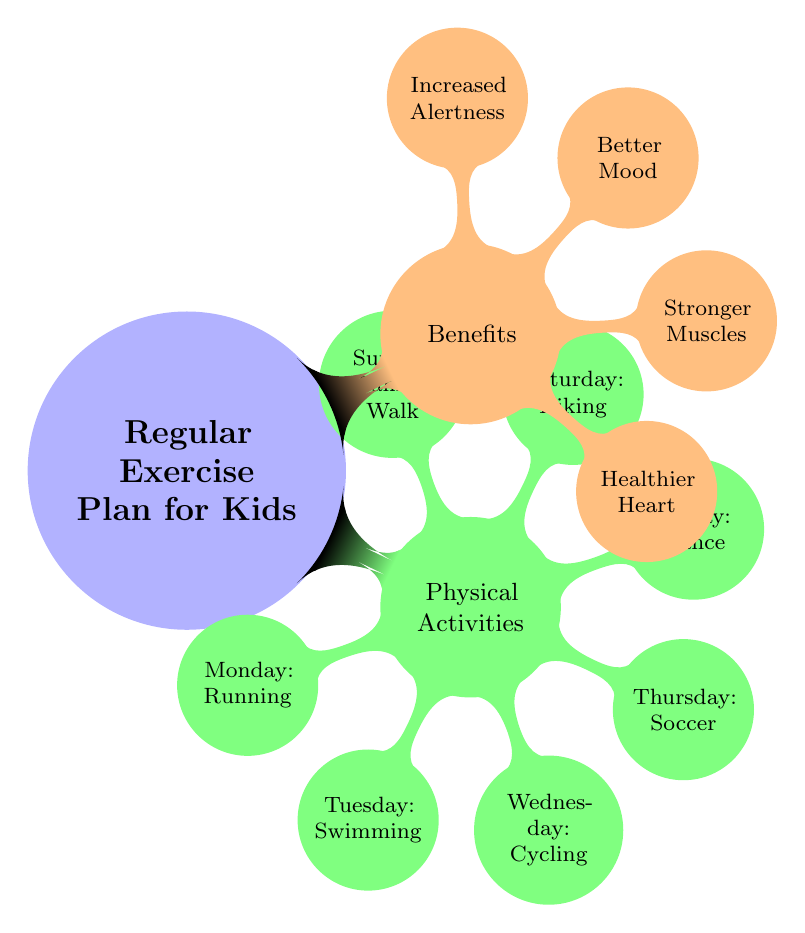What's the main topic of the diagram? The central node of the diagram is "Regular Exercise Plan for Kids," which serves as the main topic that branches out into specific activities and benefits.
Answer: Regular Exercise Plan for Kids How many physical activities are listed? There are seven branches under the "Physical Activities" node, indicating a total of seven activities arranged for each day of the week.
Answer: 7 What activity is scheduled for Thursday? The diagram specifies that "Soccer" is the activity for Thursday, as it is a direct child node stemming from the "Physical Activities" node for that day.
Answer: Soccer Which benefit identifies emotional improvement? The "Better Mood" node linked under the "Benefits" category specifically addresses emotional well-being and improvement as a result of regular exercise.
Answer: Better Mood What is the connection between physical activities and benefits? The diagram shows that physical activities directly lead to benefits, indicating a cause-and-effect relationship where engaging in activities contributes to improved health and wellness.
Answer: Cause-and-effect relationship What day of the week is designated for swimming? The diagram clearly indicates that "Swimming" is the assigned activity for Tuesday, as shown in the children nodes of the physical activities section.
Answer: Tuesday Which activity is listed for the weekend? The "Hiking" activity is scheduled for Saturday, and "Family Walk" is for Sunday, making these the weekend activities.
Answer: Hiking, Family Walk What benefit is related to physical fitness? "Stronger Muscles" is the benefit that pertains to the improvement of physical fitness due to regular exercise as shown in the benefits section.
Answer: Stronger Muscles What is the total number of benefits identified in the chart? The chart lists four distinct benefits under the "Benefits" node, which are essential outcomes of regular exercise.
Answer: 4 